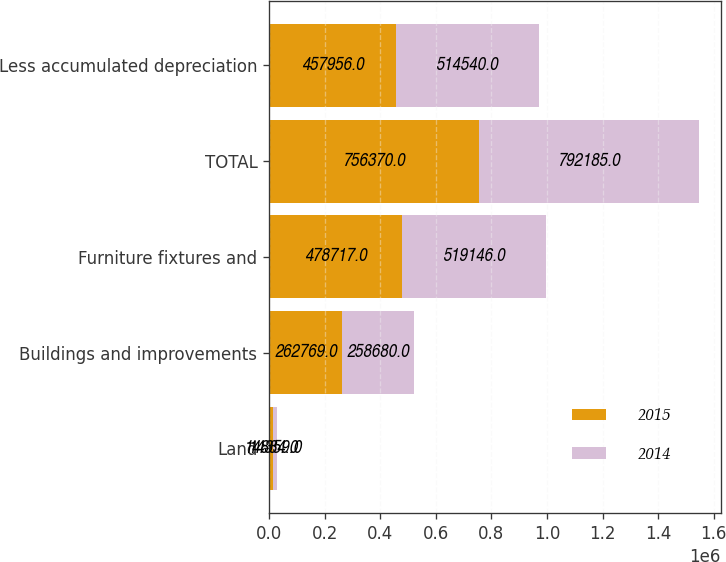Convert chart to OTSL. <chart><loc_0><loc_0><loc_500><loc_500><stacked_bar_chart><ecel><fcel>Land<fcel>Buildings and improvements<fcel>Furniture fixtures and<fcel>TOTAL<fcel>Less accumulated depreciation<nl><fcel>2015<fcel>14884<fcel>262769<fcel>478717<fcel>756370<fcel>457956<nl><fcel>2014<fcel>14359<fcel>258680<fcel>519146<fcel>792185<fcel>514540<nl></chart> 